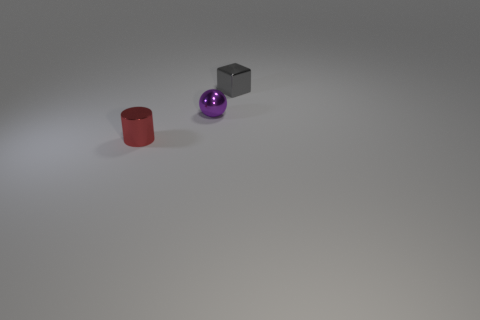How many small purple shiny things are there?
Provide a succinct answer. 1. How many blocks are purple metallic things or small red things?
Your answer should be compact. 0. There is a tiny object that is right of the tiny sphere; how many small red metal things are on the left side of it?
Your answer should be compact. 1. Are there any big cyan cylinders that have the same material as the small cylinder?
Your answer should be compact. No. How many green things are either small cylinders or large metal cylinders?
Keep it short and to the point. 0. What number of small purple objects have the same shape as the small gray thing?
Provide a short and direct response. 0. The purple object that is the same size as the block is what shape?
Provide a short and direct response. Sphere. There is a small purple shiny object; are there any tiny purple metal objects to the left of it?
Provide a short and direct response. No. There is a small object behind the purple metal object; are there any metallic blocks left of it?
Offer a terse response. No. Are there fewer small gray cubes in front of the red cylinder than metallic spheres that are in front of the purple metallic sphere?
Offer a very short reply. No. 